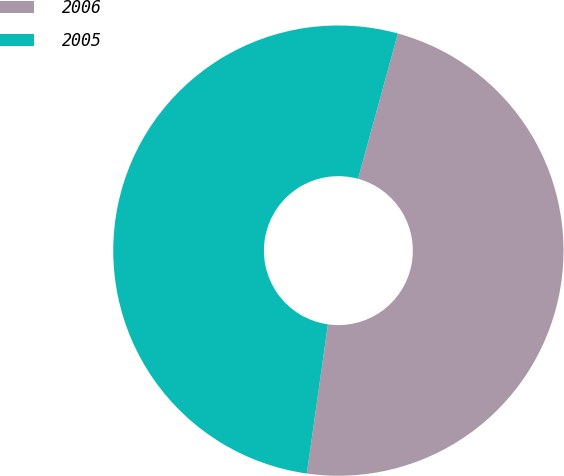<chart> <loc_0><loc_0><loc_500><loc_500><pie_chart><fcel>2006<fcel>2005<nl><fcel>47.98%<fcel>52.02%<nl></chart> 